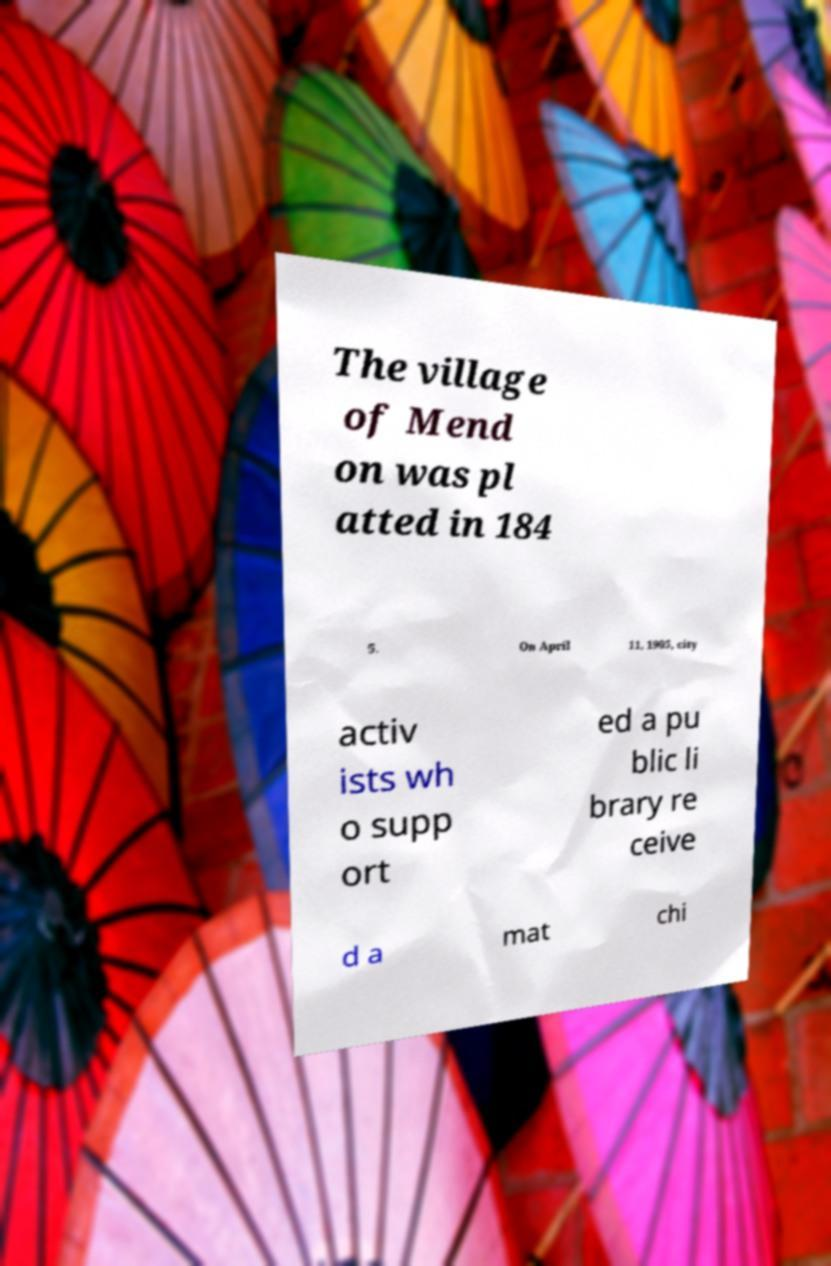Can you read and provide the text displayed in the image?This photo seems to have some interesting text. Can you extract and type it out for me? The village of Mend on was pl atted in 184 5. On April 11, 1905, city activ ists wh o supp ort ed a pu blic li brary re ceive d a mat chi 